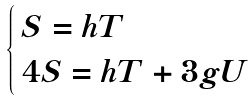Convert formula to latex. <formula><loc_0><loc_0><loc_500><loc_500>\begin{cases} \, S = h T \\ \, 4 S = h T + 3 g U \end{cases}</formula> 